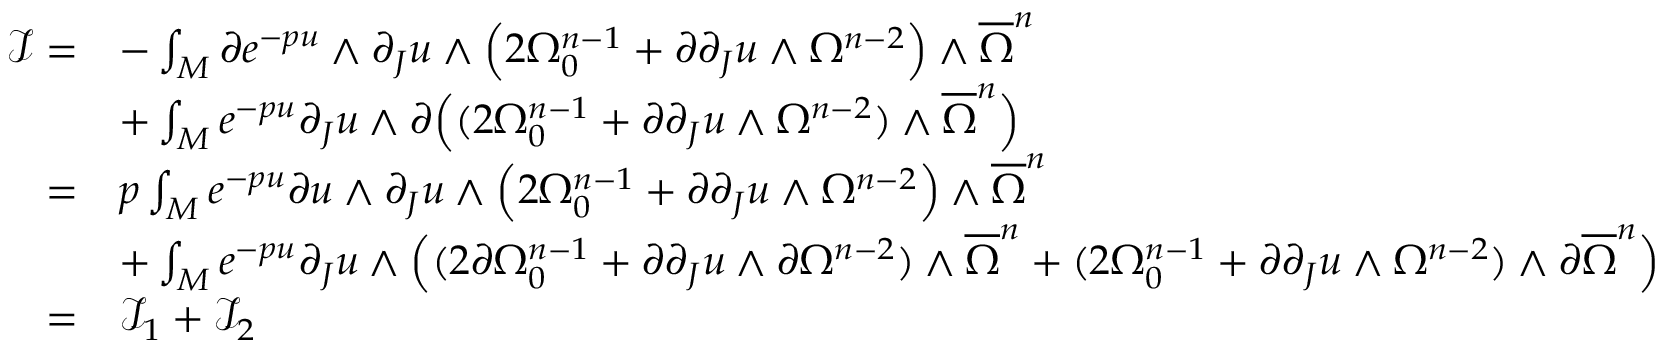Convert formula to latex. <formula><loc_0><loc_0><loc_500><loc_500>\begin{array} { r l } { \mathcal { I } = } & { - \int _ { M } \partial e ^ { - p u } \wedge \partial _ { J } u \wedge \left ( 2 \Omega _ { 0 } ^ { n - 1 } + \partial \partial _ { J } u \wedge \Omega ^ { n - 2 } \right ) \wedge { \overline { \Omega } } ^ { n } } \\ & { + \int _ { M } e ^ { - p u } \partial _ { J } u \wedge \partial \left ( ( 2 \Omega _ { 0 } ^ { n - 1 } + \partial \partial _ { J } u \wedge \Omega ^ { n - 2 } ) \wedge { \overline { \Omega } } ^ { n } \right ) } \\ { = } & { p \int _ { M } e ^ { - p u } \partial u \wedge \partial _ { J } u \wedge \left ( 2 \Omega _ { 0 } ^ { n - 1 } + \partial \partial _ { J } u \wedge \Omega ^ { n - 2 } \right ) \wedge { \overline { \Omega } } ^ { n } } \\ & { + \int _ { M } e ^ { - p u } \partial _ { J } u \wedge \left ( ( 2 \partial \Omega _ { 0 } ^ { n - 1 } + \partial \partial _ { J } u \wedge \partial \Omega ^ { n - 2 } ) \wedge { \overline { \Omega } } ^ { n } + ( 2 \Omega _ { 0 } ^ { n - 1 } + \partial \partial _ { J } u \wedge \Omega ^ { n - 2 } ) \wedge \partial { \overline { \Omega } } ^ { n } \right ) } \\ { = } & { \mathcal { I } _ { 1 } + \mathcal { I } _ { 2 } } \end{array}</formula> 